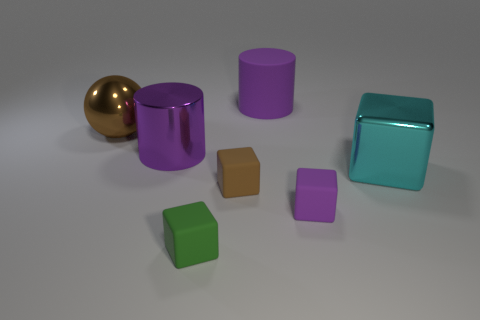How many cubes are either large gray metallic objects or large purple metallic objects?
Provide a short and direct response. 0. There is a large purple cylinder that is in front of the big metallic sphere; what number of tiny green rubber blocks are on the left side of it?
Provide a succinct answer. 0. Does the big cyan metal thing have the same shape as the tiny green object?
Offer a terse response. Yes. What size is the cyan shiny object that is the same shape as the green matte object?
Offer a terse response. Large. There is a tiny rubber thing to the right of the purple cylinder behind the large purple metallic object; what shape is it?
Your answer should be compact. Cube. How big is the purple rubber cylinder?
Make the answer very short. Large. What is the shape of the big purple matte thing?
Keep it short and to the point. Cylinder. Does the small purple object have the same shape as the tiny rubber object on the left side of the small brown matte object?
Offer a very short reply. Yes. Do the purple object that is behind the big brown ball and the big purple metallic thing have the same shape?
Provide a short and direct response. Yes. What number of objects are both behind the brown rubber thing and right of the brown metal thing?
Make the answer very short. 3. 